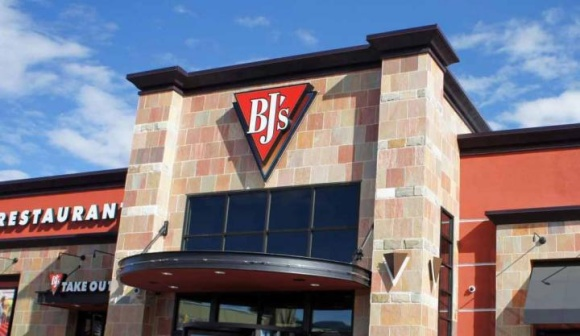What kind of atmosphere does the exterior of BJ's Restaurant and Brewhouse suggest? The exterior of BJ's Restaurant and Brewhouse suggests a lively and inviting atmosphere. The clean and well-maintained frontage, combined with bold signage and a friendly awning over the entrance, implies a place where families and friends could enjoy a casual dining experience. 